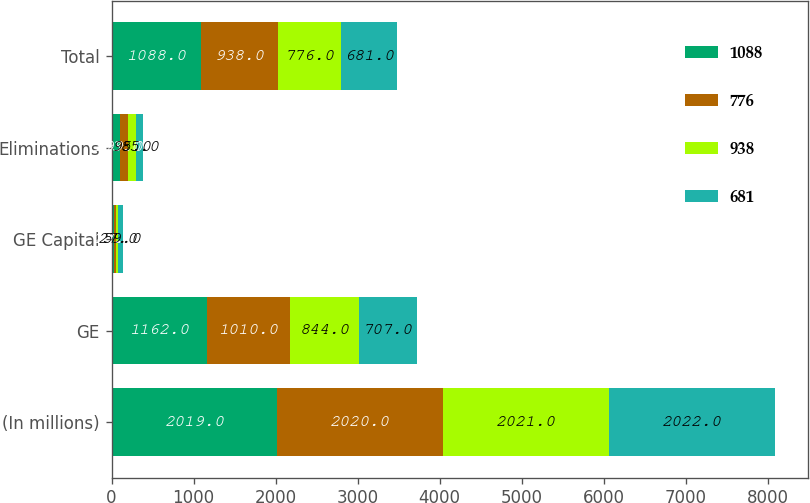Convert chart. <chart><loc_0><loc_0><loc_500><loc_500><stacked_bar_chart><ecel><fcel>(In millions)<fcel>GE<fcel>GE Capital<fcel>Eliminations<fcel>Total<nl><fcel>1088<fcel>2019<fcel>1162<fcel>29<fcel>103<fcel>1088<nl><fcel>776<fcel>2020<fcel>1010<fcel>27<fcel>99<fcel>938<nl><fcel>938<fcel>2021<fcel>844<fcel>27<fcel>95<fcel>776<nl><fcel>681<fcel>2022<fcel>707<fcel>59<fcel>85<fcel>681<nl></chart> 